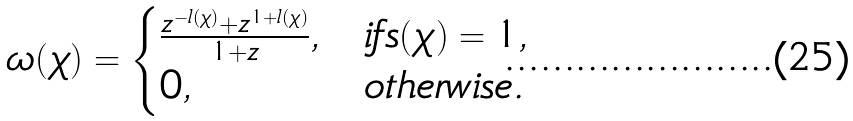<formula> <loc_0><loc_0><loc_500><loc_500>\omega ( \chi ) = \begin{cases} \frac { z ^ { - l ( \chi ) } + z ^ { 1 + l ( \chi ) } } { 1 + z } , & i f s ( \chi ) = 1 , \\ 0 , & o t h e r w i s e . \end{cases}</formula> 